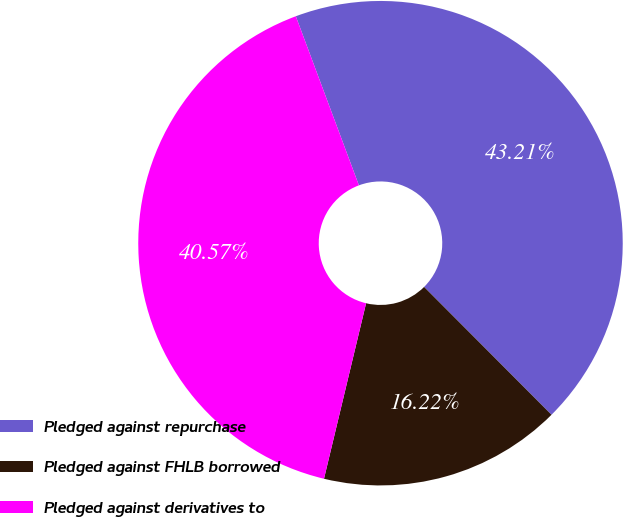<chart> <loc_0><loc_0><loc_500><loc_500><pie_chart><fcel>Pledged against repurchase<fcel>Pledged against FHLB borrowed<fcel>Pledged against derivatives to<nl><fcel>43.21%<fcel>16.22%<fcel>40.57%<nl></chart> 